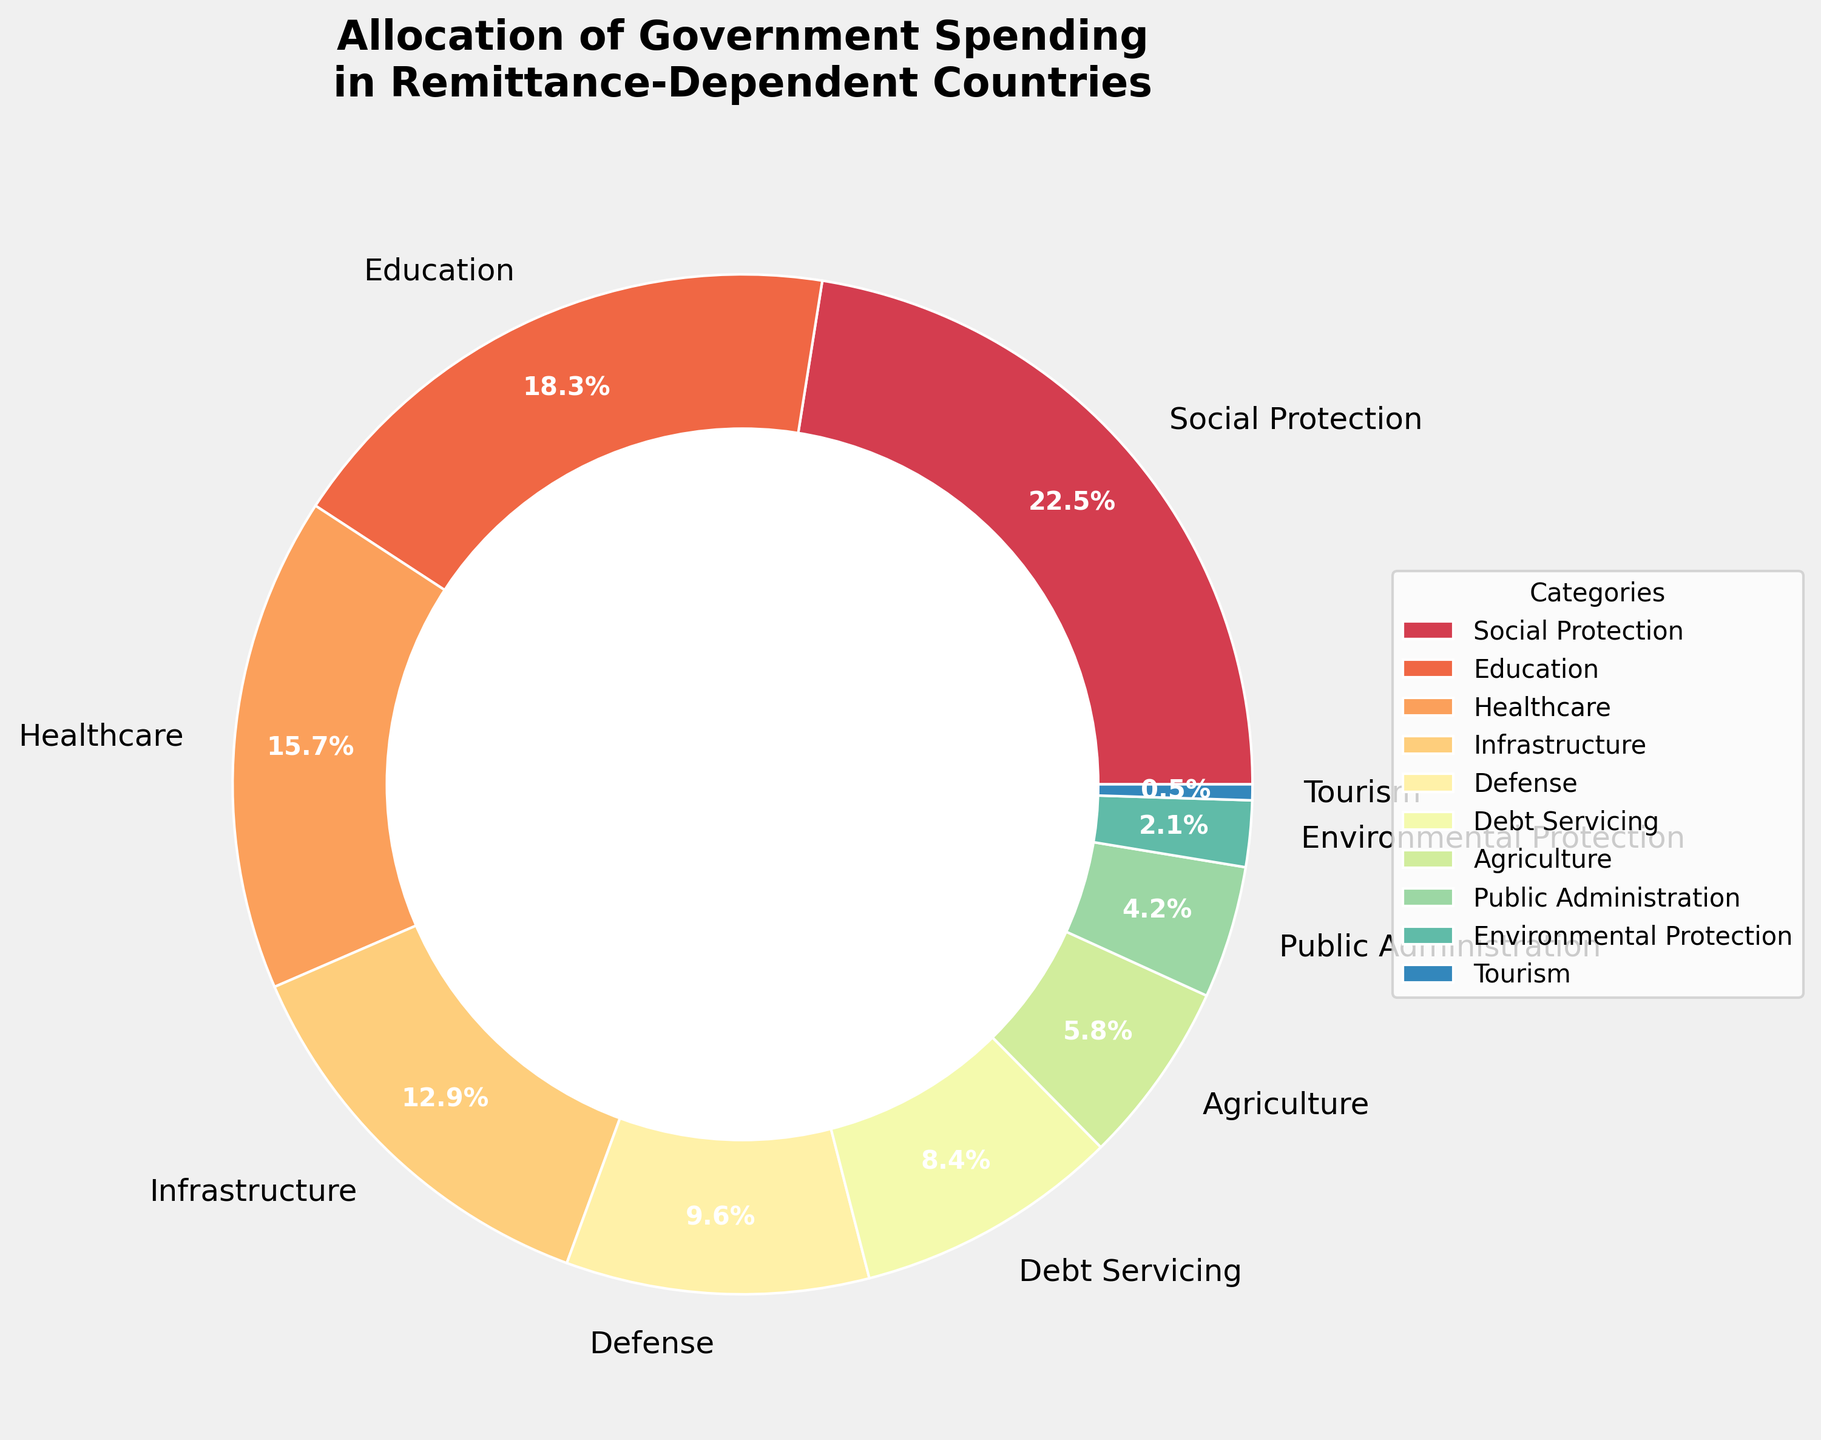What percentage of government spending is allocated to Defense and Healthcare combined? To find the total percentage allocated to Defense and Healthcare, add the percentages for Defense (9.6%) and Healthcare (15.7%). Thus, 9.6 + 15.7 = 25.3.
Answer: 25.3% Which category receives the highest percentage of government spending? By looking at the chart, the largest wedge represents the highest percentage. That wedge is labeled "Social Protection" with 22.5%.
Answer: Social Protection Between Education and Infrastructure, which category receives more government spending? By comparing the two percentages, Education receives 18.3% and Infrastructure receives 12.9%. Education, therefore, receives more.
Answer: Education What is the difference in the percentage allocated to Education and Debt Servicing? To find the difference, subtract the percentage for Debt Servicing (8.4%) from the percentage for Education (18.3%). Thus, 18.3 - 8.4 = 9.9.
Answer: 9.9% What is the total percentage allocated to Agriculture, Environmental Protection, and Tourism combined? To find the total percentage for these categories, add their respective percentages: Agriculture (5.8%), Environmental Protection (2.1%), and Tourism (0.5%). Thus, 5.8 + 2.1 + 0.5 = 8.4.
Answer: 8.4% Among the categories, which one has a significantly lower allocation compared to Defense? Defense is allocated 9.6% and the smallest allocation is for Tourism at 0.5%. Therefore, Tourism has a significantly lower allocation compared to Defense.
Answer: Tourism What is the percentage allocation for categories that receive under 10% of government spending each? Categories under 10% allocation include Defense (9.6%), Debt Servicing (8.4%), Agriculture (5.8%), Public Administration (4.2%), Environmental Protection (2.1%), and Tourism (0.5%). Adding them up gives 9.6 + 8.4 + 5.8 + 4.2 + 2.1 + 0.5 = 30.6.
Answer: 30.6% If you were to create a subgroup of categories related to 'Public Welfare' by combining Social Protection, Healthcare, and Education, what would be their total share? Combine the percentages for Social Protection (22.5%), Healthcare (15.7%), and Education (18.3%). Thus, 22.5 + 15.7 + 18.3 = 56.5.
Answer: 56.5% What color represents the Healthcare category in the pie chart? By examining the chart, Healthcare is represented by a distinct color which can be identified visually. The specific color was assigned in the plot creation but needs to be observed directly on the chart.
Answer: Check the chart for visual identification What is the average percentage allocation across all categories? There are 10 categories in total. To find the average, sum the percentages of all categories and divide by 10. So, (22.5 + 18.3 + 15.7 + 12.9 + 9.6 + 8.4 + 5.8 + 4.2 + 2.1 + 0.5) / 10 = 100 / 10 = 10%.
Answer: 10% 